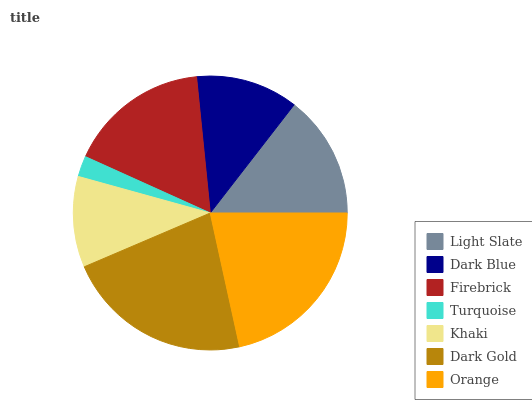Is Turquoise the minimum?
Answer yes or no. Yes. Is Dark Gold the maximum?
Answer yes or no. Yes. Is Dark Blue the minimum?
Answer yes or no. No. Is Dark Blue the maximum?
Answer yes or no. No. Is Light Slate greater than Dark Blue?
Answer yes or no. Yes. Is Dark Blue less than Light Slate?
Answer yes or no. Yes. Is Dark Blue greater than Light Slate?
Answer yes or no. No. Is Light Slate less than Dark Blue?
Answer yes or no. No. Is Light Slate the high median?
Answer yes or no. Yes. Is Light Slate the low median?
Answer yes or no. Yes. Is Turquoise the high median?
Answer yes or no. No. Is Firebrick the low median?
Answer yes or no. No. 